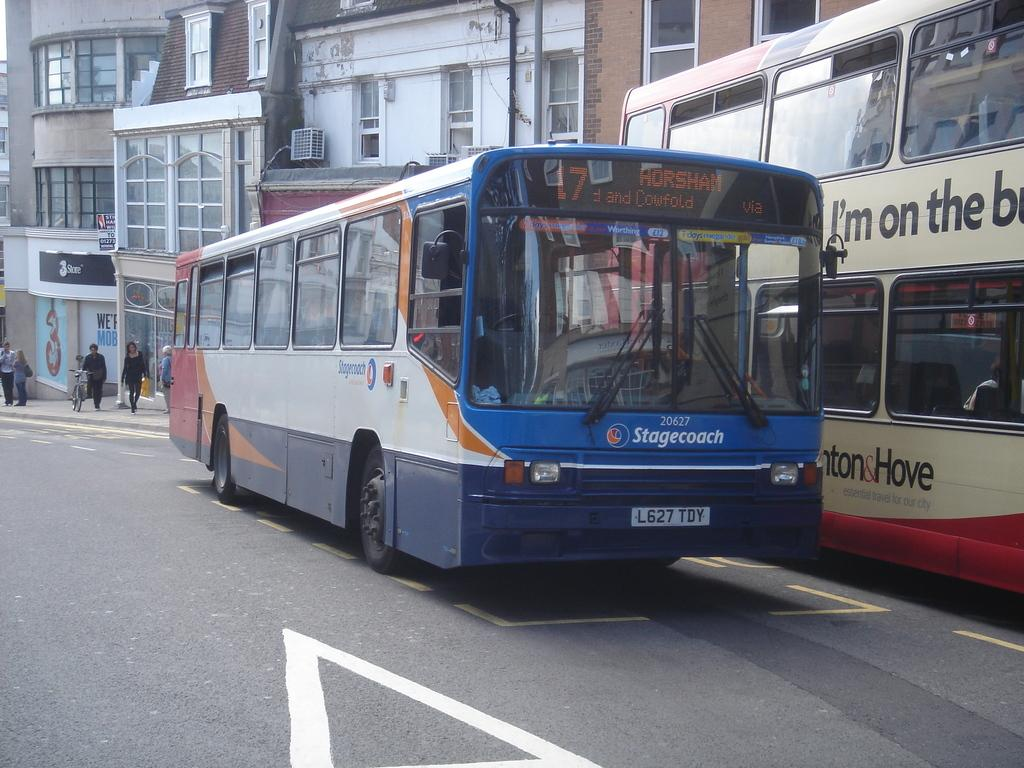Provide a one-sentence caption for the provided image. Bus 17 passes another bus on its way to Horsham. 